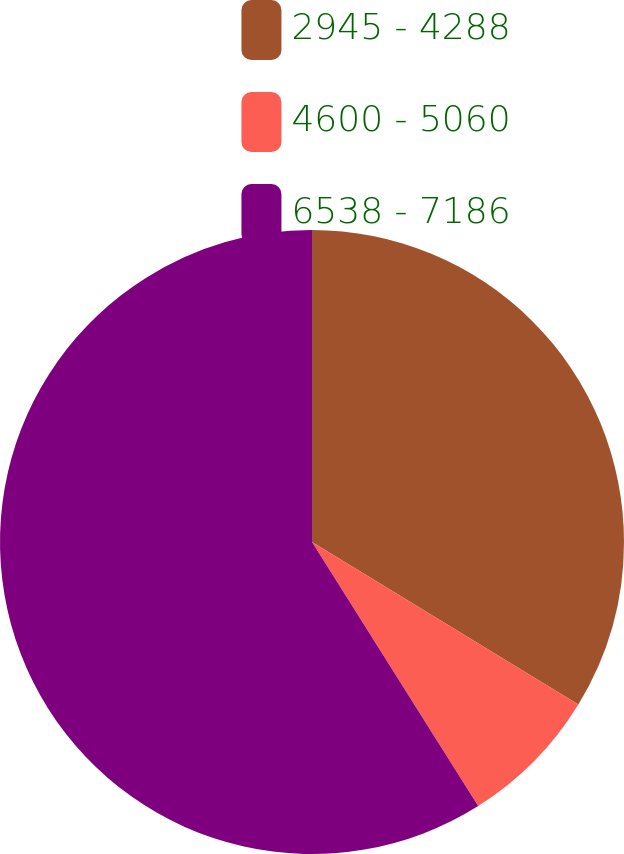<chart> <loc_0><loc_0><loc_500><loc_500><pie_chart><fcel>2945 - 4288<fcel>4600 - 5060<fcel>6538 - 7186<nl><fcel>33.72%<fcel>7.34%<fcel>58.94%<nl></chart> 